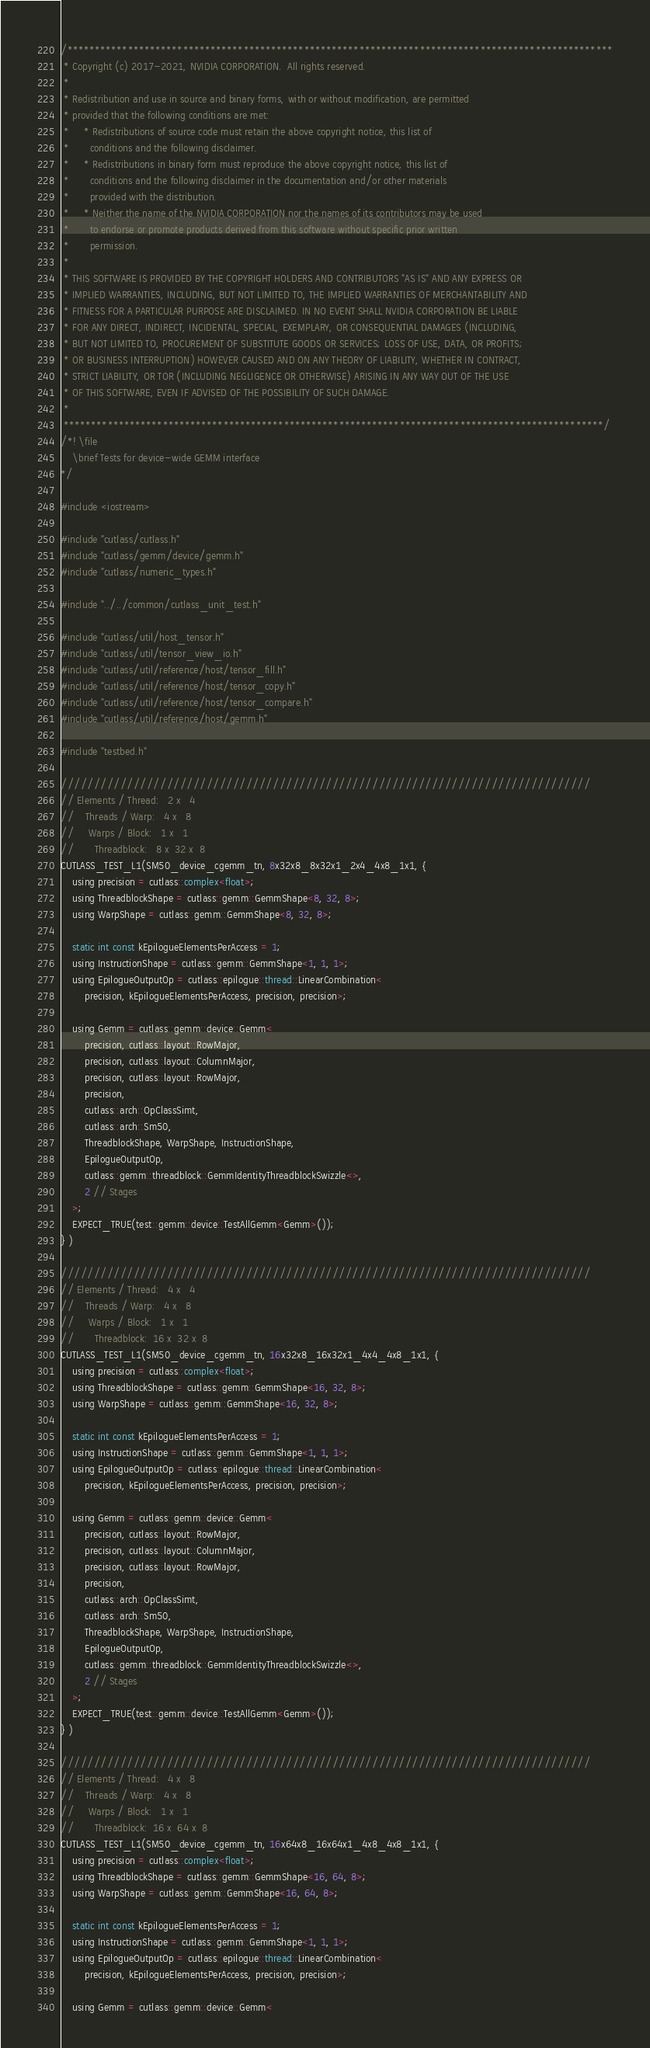<code> <loc_0><loc_0><loc_500><loc_500><_Cuda_>/***************************************************************************************************
 * Copyright (c) 2017-2021, NVIDIA CORPORATION.  All rights reserved.
 *
 * Redistribution and use in source and binary forms, with or without modification, are permitted
 * provided that the following conditions are met:
 *     * Redistributions of source code must retain the above copyright notice, this list of
 *       conditions and the following disclaimer.
 *     * Redistributions in binary form must reproduce the above copyright notice, this list of
 *       conditions and the following disclaimer in the documentation and/or other materials
 *       provided with the distribution.
 *     * Neither the name of the NVIDIA CORPORATION nor the names of its contributors may be used
 *       to endorse or promote products derived from this software without specific prior written
 *       permission.
 *
 * THIS SOFTWARE IS PROVIDED BY THE COPYRIGHT HOLDERS AND CONTRIBUTORS "AS IS" AND ANY EXPRESS OR
 * IMPLIED WARRANTIES, INCLUDING, BUT NOT LIMITED TO, THE IMPLIED WARRANTIES OF MERCHANTABILITY AND
 * FITNESS FOR A PARTICULAR PURPOSE ARE DISCLAIMED. IN NO EVENT SHALL NVIDIA CORPORATION BE LIABLE
 * FOR ANY DIRECT, INDIRECT, INCIDENTAL, SPECIAL, EXEMPLARY, OR CONSEQUENTIAL DAMAGES (INCLUDING,
 * BUT NOT LIMITED TO, PROCUREMENT OF SUBSTITUTE GOODS OR SERVICES; LOSS OF USE, DATA, OR PROFITS;
 * OR BUSINESS INTERRUPTION) HOWEVER CAUSED AND ON ANY THEORY OF LIABILITY, WHETHER IN CONTRACT,
 * STRICT LIABILITY, OR TOR (INCLUDING NEGLIGENCE OR OTHERWISE) ARISING IN ANY WAY OUT OF THE USE
 * OF THIS SOFTWARE, EVEN IF ADVISED OF THE POSSIBILITY OF SUCH DAMAGE.
 *
 **************************************************************************************************/
/*! \file
    \brief Tests for device-wide GEMM interface
*/

#include <iostream>

#include "cutlass/cutlass.h"
#include "cutlass/gemm/device/gemm.h"
#include "cutlass/numeric_types.h"

#include "../../common/cutlass_unit_test.h"

#include "cutlass/util/host_tensor.h"
#include "cutlass/util/tensor_view_io.h"
#include "cutlass/util/reference/host/tensor_fill.h"
#include "cutlass/util/reference/host/tensor_copy.h"
#include "cutlass/util/reference/host/tensor_compare.h"
#include "cutlass/util/reference/host/gemm.h"

#include "testbed.h"

////////////////////////////////////////////////////////////////////////////////
// Elements / Thread:   2 x   4
//    Threads / Warp:   4 x   8
//     Warps / Block:   1 x   1
//       Threadblock:   8 x  32 x  8
CUTLASS_TEST_L1(SM50_device_cgemm_tn, 8x32x8_8x32x1_2x4_4x8_1x1, {
    using precision = cutlass::complex<float>;
    using ThreadblockShape = cutlass::gemm::GemmShape<8, 32, 8>;
    using WarpShape = cutlass::gemm::GemmShape<8, 32, 8>;

    static int const kEpilogueElementsPerAccess = 1;
    using InstructionShape = cutlass::gemm::GemmShape<1, 1, 1>;
    using EpilogueOutputOp = cutlass::epilogue::thread::LinearCombination<
        precision, kEpilogueElementsPerAccess, precision, precision>;

    using Gemm = cutlass::gemm::device::Gemm<
        precision, cutlass::layout::RowMajor,
        precision, cutlass::layout::ColumnMajor,
        precision, cutlass::layout::RowMajor,
        precision,
        cutlass::arch::OpClassSimt,
        cutlass::arch::Sm50,
        ThreadblockShape, WarpShape, InstructionShape,
        EpilogueOutputOp,
        cutlass::gemm::threadblock::GemmIdentityThreadblockSwizzle<>,
        2 // Stages
    >;
    EXPECT_TRUE(test::gemm::device::TestAllGemm<Gemm>());
} )

////////////////////////////////////////////////////////////////////////////////
// Elements / Thread:   4 x   4
//    Threads / Warp:   4 x   8
//     Warps / Block:   1 x   1
//       Threadblock:  16 x  32 x  8
CUTLASS_TEST_L1(SM50_device_cgemm_tn, 16x32x8_16x32x1_4x4_4x8_1x1, {
    using precision = cutlass::complex<float>;
    using ThreadblockShape = cutlass::gemm::GemmShape<16, 32, 8>;
    using WarpShape = cutlass::gemm::GemmShape<16, 32, 8>;

    static int const kEpilogueElementsPerAccess = 1;
    using InstructionShape = cutlass::gemm::GemmShape<1, 1, 1>;
    using EpilogueOutputOp = cutlass::epilogue::thread::LinearCombination<
        precision, kEpilogueElementsPerAccess, precision, precision>;

    using Gemm = cutlass::gemm::device::Gemm<
        precision, cutlass::layout::RowMajor,
        precision, cutlass::layout::ColumnMajor,
        precision, cutlass::layout::RowMajor,
        precision,
        cutlass::arch::OpClassSimt,
        cutlass::arch::Sm50,
        ThreadblockShape, WarpShape, InstructionShape,
        EpilogueOutputOp,
        cutlass::gemm::threadblock::GemmIdentityThreadblockSwizzle<>,
        2 // Stages
    >;
    EXPECT_TRUE(test::gemm::device::TestAllGemm<Gemm>());
} )

////////////////////////////////////////////////////////////////////////////////
// Elements / Thread:   4 x   8
//    Threads / Warp:   4 x   8
//     Warps / Block:   1 x   1
//       Threadblock:  16 x  64 x  8
CUTLASS_TEST_L1(SM50_device_cgemm_tn, 16x64x8_16x64x1_4x8_4x8_1x1, {
    using precision = cutlass::complex<float>;
    using ThreadblockShape = cutlass::gemm::GemmShape<16, 64, 8>;
    using WarpShape = cutlass::gemm::GemmShape<16, 64, 8>;

    static int const kEpilogueElementsPerAccess = 1;
    using InstructionShape = cutlass::gemm::GemmShape<1, 1, 1>;
    using EpilogueOutputOp = cutlass::epilogue::thread::LinearCombination<
        precision, kEpilogueElementsPerAccess, precision, precision>;

    using Gemm = cutlass::gemm::device::Gemm<</code> 